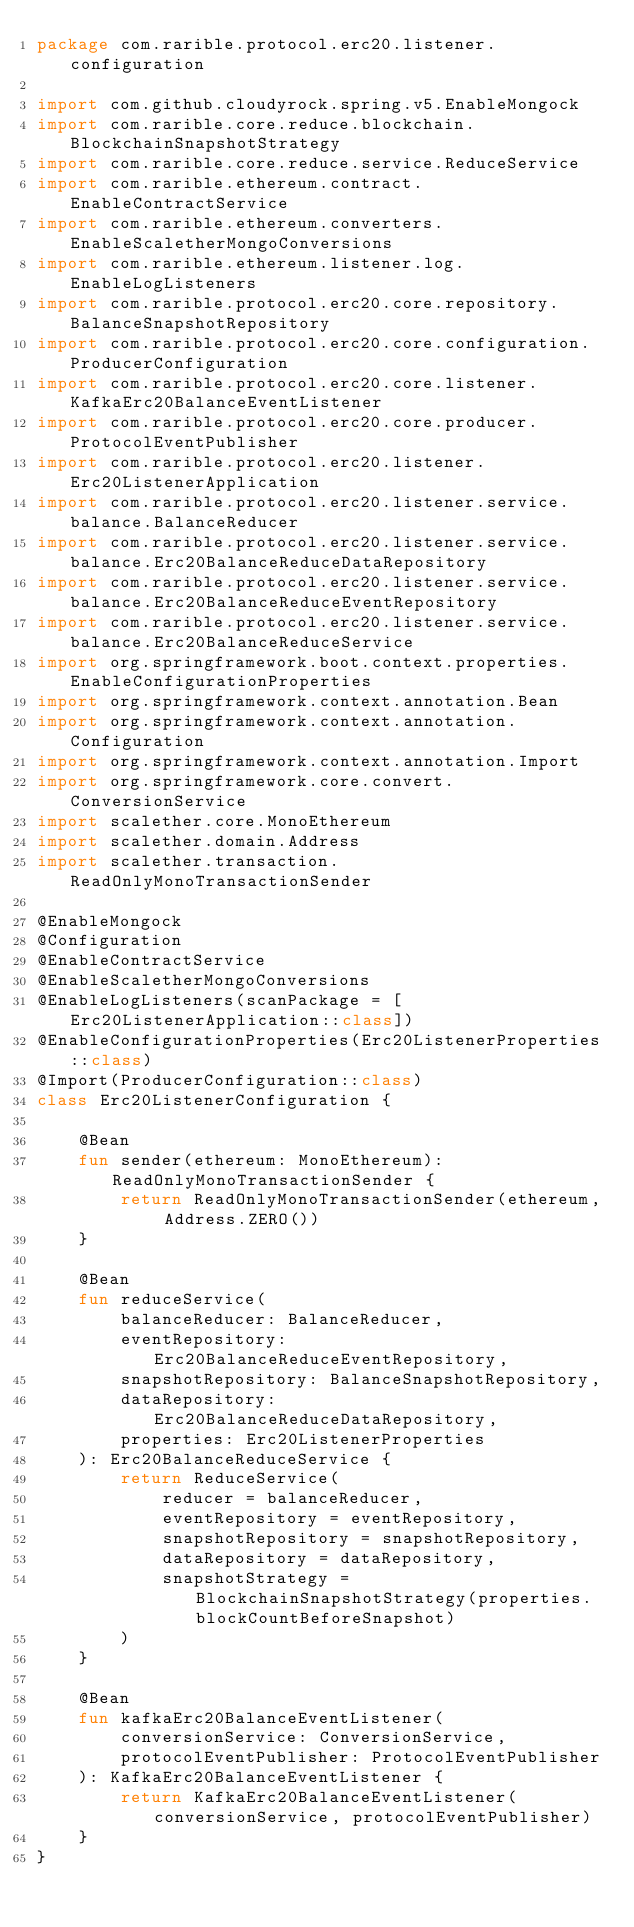Convert code to text. <code><loc_0><loc_0><loc_500><loc_500><_Kotlin_>package com.rarible.protocol.erc20.listener.configuration

import com.github.cloudyrock.spring.v5.EnableMongock
import com.rarible.core.reduce.blockchain.BlockchainSnapshotStrategy
import com.rarible.core.reduce.service.ReduceService
import com.rarible.ethereum.contract.EnableContractService
import com.rarible.ethereum.converters.EnableScaletherMongoConversions
import com.rarible.ethereum.listener.log.EnableLogListeners
import com.rarible.protocol.erc20.core.repository.BalanceSnapshotRepository
import com.rarible.protocol.erc20.core.configuration.ProducerConfiguration
import com.rarible.protocol.erc20.core.listener.KafkaErc20BalanceEventListener
import com.rarible.protocol.erc20.core.producer.ProtocolEventPublisher
import com.rarible.protocol.erc20.listener.Erc20ListenerApplication
import com.rarible.protocol.erc20.listener.service.balance.BalanceReducer
import com.rarible.protocol.erc20.listener.service.balance.Erc20BalanceReduceDataRepository
import com.rarible.protocol.erc20.listener.service.balance.Erc20BalanceReduceEventRepository
import com.rarible.protocol.erc20.listener.service.balance.Erc20BalanceReduceService
import org.springframework.boot.context.properties.EnableConfigurationProperties
import org.springframework.context.annotation.Bean
import org.springframework.context.annotation.Configuration
import org.springframework.context.annotation.Import
import org.springframework.core.convert.ConversionService
import scalether.core.MonoEthereum
import scalether.domain.Address
import scalether.transaction.ReadOnlyMonoTransactionSender

@EnableMongock
@Configuration
@EnableContractService
@EnableScaletherMongoConversions
@EnableLogListeners(scanPackage = [Erc20ListenerApplication::class])
@EnableConfigurationProperties(Erc20ListenerProperties::class)
@Import(ProducerConfiguration::class)
class Erc20ListenerConfiguration {

    @Bean
    fun sender(ethereum: MonoEthereum): ReadOnlyMonoTransactionSender {
        return ReadOnlyMonoTransactionSender(ethereum, Address.ZERO())
    }

    @Bean
    fun reduceService(
        balanceReducer: BalanceReducer,
        eventRepository: Erc20BalanceReduceEventRepository,
        snapshotRepository: BalanceSnapshotRepository,
        dataRepository: Erc20BalanceReduceDataRepository,
        properties: Erc20ListenerProperties
    ): Erc20BalanceReduceService {
        return ReduceService(
            reducer = balanceReducer,
            eventRepository = eventRepository,
            snapshotRepository = snapshotRepository,
            dataRepository = dataRepository,
            snapshotStrategy = BlockchainSnapshotStrategy(properties.blockCountBeforeSnapshot)
        )
    }

    @Bean
    fun kafkaErc20BalanceEventListener(
        conversionService: ConversionService,
        protocolEventPublisher: ProtocolEventPublisher
    ): KafkaErc20BalanceEventListener {
        return KafkaErc20BalanceEventListener(conversionService, protocolEventPublisher)
    }
}
</code> 